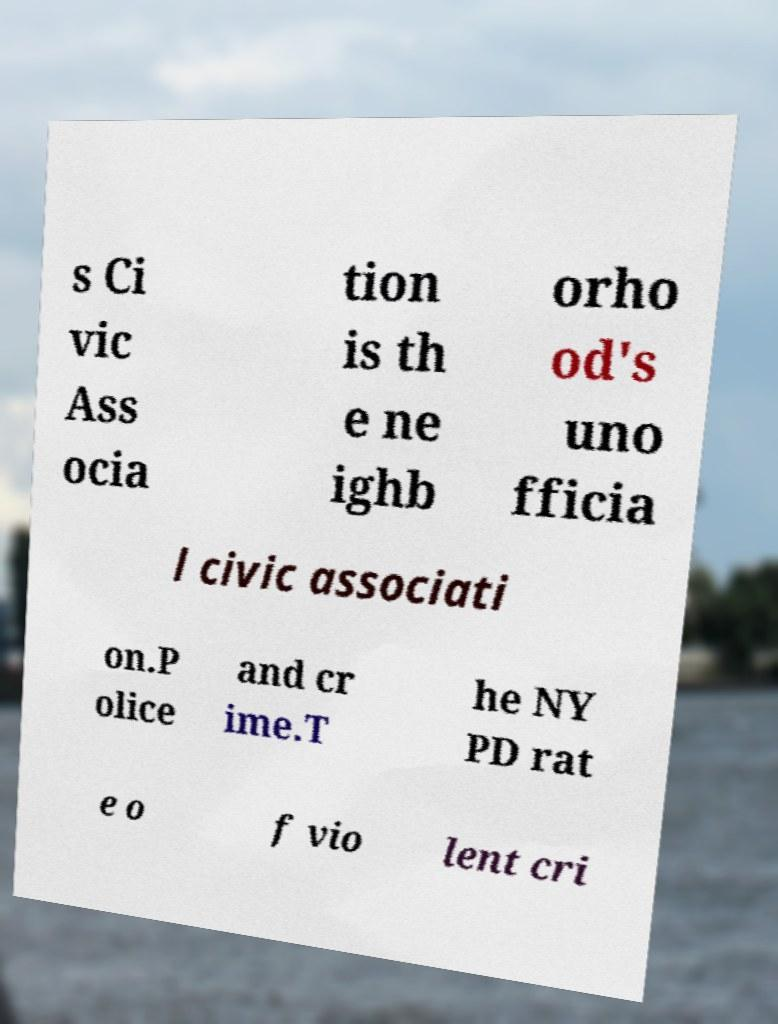Can you read and provide the text displayed in the image?This photo seems to have some interesting text. Can you extract and type it out for me? s Ci vic Ass ocia tion is th e ne ighb orho od's uno fficia l civic associati on.P olice and cr ime.T he NY PD rat e o f vio lent cri 